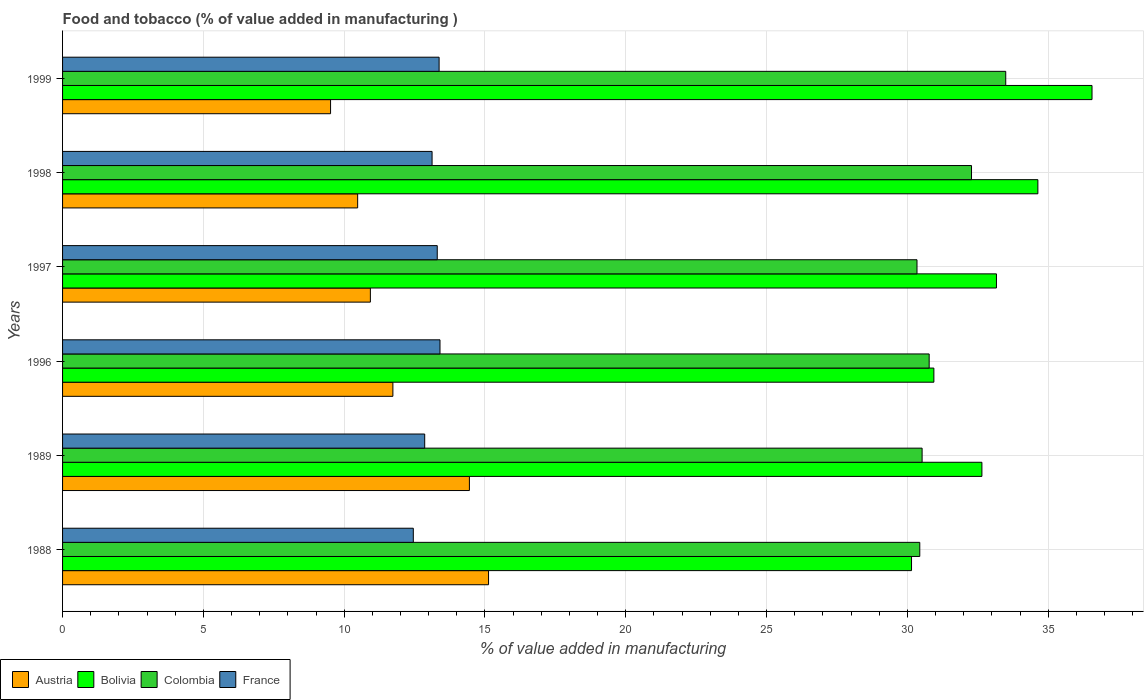How many bars are there on the 6th tick from the top?
Provide a succinct answer. 4. What is the label of the 1st group of bars from the top?
Ensure brevity in your answer.  1999. What is the value added in manufacturing food and tobacco in Bolivia in 1999?
Make the answer very short. 36.56. Across all years, what is the maximum value added in manufacturing food and tobacco in Colombia?
Offer a very short reply. 33.49. Across all years, what is the minimum value added in manufacturing food and tobacco in France?
Your response must be concise. 12.45. In which year was the value added in manufacturing food and tobacco in Austria maximum?
Make the answer very short. 1988. What is the total value added in manufacturing food and tobacco in Bolivia in the graph?
Your answer should be very brief. 198.08. What is the difference between the value added in manufacturing food and tobacco in Bolivia in 1996 and that in 1997?
Your answer should be compact. -2.22. What is the difference between the value added in manufacturing food and tobacco in France in 1998 and the value added in manufacturing food and tobacco in Austria in 1997?
Offer a very short reply. 2.19. What is the average value added in manufacturing food and tobacco in Colombia per year?
Give a very brief answer. 31.31. In the year 1997, what is the difference between the value added in manufacturing food and tobacco in France and value added in manufacturing food and tobacco in Austria?
Give a very brief answer. 2.37. What is the ratio of the value added in manufacturing food and tobacco in France in 1988 to that in 1997?
Give a very brief answer. 0.94. Is the value added in manufacturing food and tobacco in Austria in 1988 less than that in 1989?
Provide a succinct answer. No. What is the difference between the highest and the second highest value added in manufacturing food and tobacco in Colombia?
Give a very brief answer. 1.22. What is the difference between the highest and the lowest value added in manufacturing food and tobacco in Bolivia?
Provide a short and direct response. 6.41. In how many years, is the value added in manufacturing food and tobacco in France greater than the average value added in manufacturing food and tobacco in France taken over all years?
Provide a succinct answer. 4. Is the sum of the value added in manufacturing food and tobacco in Austria in 1989 and 1999 greater than the maximum value added in manufacturing food and tobacco in France across all years?
Offer a terse response. Yes. What does the 3rd bar from the bottom in 1996 represents?
Give a very brief answer. Colombia. Is it the case that in every year, the sum of the value added in manufacturing food and tobacco in Colombia and value added in manufacturing food and tobacco in Bolivia is greater than the value added in manufacturing food and tobacco in Austria?
Your answer should be compact. Yes. How many bars are there?
Keep it short and to the point. 24. Does the graph contain any zero values?
Your answer should be very brief. No. How are the legend labels stacked?
Your response must be concise. Horizontal. What is the title of the graph?
Offer a terse response. Food and tobacco (% of value added in manufacturing ). Does "Bosnia and Herzegovina" appear as one of the legend labels in the graph?
Ensure brevity in your answer.  No. What is the label or title of the X-axis?
Provide a succinct answer. % of value added in manufacturing. What is the label or title of the Y-axis?
Offer a very short reply. Years. What is the % of value added in manufacturing of Austria in 1988?
Provide a short and direct response. 15.13. What is the % of value added in manufacturing of Bolivia in 1988?
Offer a terse response. 30.15. What is the % of value added in manufacturing in Colombia in 1988?
Your response must be concise. 30.44. What is the % of value added in manufacturing in France in 1988?
Keep it short and to the point. 12.45. What is the % of value added in manufacturing of Austria in 1989?
Ensure brevity in your answer.  14.45. What is the % of value added in manufacturing in Bolivia in 1989?
Provide a short and direct response. 32.65. What is the % of value added in manufacturing of Colombia in 1989?
Your response must be concise. 30.52. What is the % of value added in manufacturing of France in 1989?
Ensure brevity in your answer.  12.86. What is the % of value added in manufacturing of Austria in 1996?
Offer a terse response. 11.73. What is the % of value added in manufacturing in Bolivia in 1996?
Offer a terse response. 30.94. What is the % of value added in manufacturing of Colombia in 1996?
Provide a succinct answer. 30.77. What is the % of value added in manufacturing in France in 1996?
Your response must be concise. 13.4. What is the % of value added in manufacturing of Austria in 1997?
Make the answer very short. 10.93. What is the % of value added in manufacturing of Bolivia in 1997?
Keep it short and to the point. 33.16. What is the % of value added in manufacturing of Colombia in 1997?
Keep it short and to the point. 30.34. What is the % of value added in manufacturing in France in 1997?
Your answer should be compact. 13.31. What is the % of value added in manufacturing in Austria in 1998?
Provide a short and direct response. 10.48. What is the % of value added in manufacturing of Bolivia in 1998?
Your answer should be compact. 34.63. What is the % of value added in manufacturing of Colombia in 1998?
Make the answer very short. 32.28. What is the % of value added in manufacturing of France in 1998?
Give a very brief answer. 13.12. What is the % of value added in manufacturing in Austria in 1999?
Offer a terse response. 9.52. What is the % of value added in manufacturing of Bolivia in 1999?
Offer a very short reply. 36.56. What is the % of value added in manufacturing in Colombia in 1999?
Offer a terse response. 33.49. What is the % of value added in manufacturing in France in 1999?
Offer a terse response. 13.37. Across all years, what is the maximum % of value added in manufacturing of Austria?
Offer a terse response. 15.13. Across all years, what is the maximum % of value added in manufacturing of Bolivia?
Make the answer very short. 36.56. Across all years, what is the maximum % of value added in manufacturing in Colombia?
Give a very brief answer. 33.49. Across all years, what is the maximum % of value added in manufacturing in France?
Offer a very short reply. 13.4. Across all years, what is the minimum % of value added in manufacturing in Austria?
Offer a very short reply. 9.52. Across all years, what is the minimum % of value added in manufacturing in Bolivia?
Provide a short and direct response. 30.15. Across all years, what is the minimum % of value added in manufacturing in Colombia?
Ensure brevity in your answer.  30.34. Across all years, what is the minimum % of value added in manufacturing in France?
Your answer should be very brief. 12.45. What is the total % of value added in manufacturing of Austria in the graph?
Offer a terse response. 72.23. What is the total % of value added in manufacturing in Bolivia in the graph?
Keep it short and to the point. 198.08. What is the total % of value added in manufacturing of Colombia in the graph?
Your answer should be very brief. 187.85. What is the total % of value added in manufacturing of France in the graph?
Ensure brevity in your answer.  78.51. What is the difference between the % of value added in manufacturing in Austria in 1988 and that in 1989?
Provide a short and direct response. 0.68. What is the difference between the % of value added in manufacturing in Bolivia in 1988 and that in 1989?
Keep it short and to the point. -2.5. What is the difference between the % of value added in manufacturing of Colombia in 1988 and that in 1989?
Your response must be concise. -0.08. What is the difference between the % of value added in manufacturing in France in 1988 and that in 1989?
Offer a very short reply. -0.4. What is the difference between the % of value added in manufacturing of Austria in 1988 and that in 1996?
Offer a very short reply. 3.4. What is the difference between the % of value added in manufacturing of Bolivia in 1988 and that in 1996?
Your answer should be very brief. -0.79. What is the difference between the % of value added in manufacturing of Colombia in 1988 and that in 1996?
Your answer should be very brief. -0.33. What is the difference between the % of value added in manufacturing of France in 1988 and that in 1996?
Ensure brevity in your answer.  -0.95. What is the difference between the % of value added in manufacturing of Austria in 1988 and that in 1997?
Your answer should be very brief. 4.2. What is the difference between the % of value added in manufacturing of Bolivia in 1988 and that in 1997?
Offer a terse response. -3.02. What is the difference between the % of value added in manufacturing in Colombia in 1988 and that in 1997?
Your answer should be compact. 0.1. What is the difference between the % of value added in manufacturing in France in 1988 and that in 1997?
Offer a very short reply. -0.85. What is the difference between the % of value added in manufacturing of Austria in 1988 and that in 1998?
Provide a short and direct response. 4.65. What is the difference between the % of value added in manufacturing of Bolivia in 1988 and that in 1998?
Keep it short and to the point. -4.49. What is the difference between the % of value added in manufacturing of Colombia in 1988 and that in 1998?
Give a very brief answer. -1.84. What is the difference between the % of value added in manufacturing of France in 1988 and that in 1998?
Your answer should be very brief. -0.67. What is the difference between the % of value added in manufacturing of Austria in 1988 and that in 1999?
Provide a succinct answer. 5.61. What is the difference between the % of value added in manufacturing in Bolivia in 1988 and that in 1999?
Your answer should be very brief. -6.41. What is the difference between the % of value added in manufacturing in Colombia in 1988 and that in 1999?
Your response must be concise. -3.05. What is the difference between the % of value added in manufacturing of France in 1988 and that in 1999?
Your answer should be compact. -0.92. What is the difference between the % of value added in manufacturing in Austria in 1989 and that in 1996?
Ensure brevity in your answer.  2.72. What is the difference between the % of value added in manufacturing of Bolivia in 1989 and that in 1996?
Give a very brief answer. 1.71. What is the difference between the % of value added in manufacturing of Colombia in 1989 and that in 1996?
Offer a very short reply. -0.25. What is the difference between the % of value added in manufacturing in France in 1989 and that in 1996?
Give a very brief answer. -0.54. What is the difference between the % of value added in manufacturing of Austria in 1989 and that in 1997?
Ensure brevity in your answer.  3.52. What is the difference between the % of value added in manufacturing in Bolivia in 1989 and that in 1997?
Ensure brevity in your answer.  -0.52. What is the difference between the % of value added in manufacturing in Colombia in 1989 and that in 1997?
Give a very brief answer. 0.18. What is the difference between the % of value added in manufacturing of France in 1989 and that in 1997?
Provide a short and direct response. -0.45. What is the difference between the % of value added in manufacturing of Austria in 1989 and that in 1998?
Ensure brevity in your answer.  3.97. What is the difference between the % of value added in manufacturing in Bolivia in 1989 and that in 1998?
Offer a very short reply. -1.99. What is the difference between the % of value added in manufacturing of Colombia in 1989 and that in 1998?
Ensure brevity in your answer.  -1.75. What is the difference between the % of value added in manufacturing in France in 1989 and that in 1998?
Your answer should be compact. -0.26. What is the difference between the % of value added in manufacturing of Austria in 1989 and that in 1999?
Provide a succinct answer. 4.93. What is the difference between the % of value added in manufacturing of Bolivia in 1989 and that in 1999?
Keep it short and to the point. -3.91. What is the difference between the % of value added in manufacturing of Colombia in 1989 and that in 1999?
Make the answer very short. -2.97. What is the difference between the % of value added in manufacturing of France in 1989 and that in 1999?
Ensure brevity in your answer.  -0.51. What is the difference between the % of value added in manufacturing of Austria in 1996 and that in 1997?
Make the answer very short. 0.8. What is the difference between the % of value added in manufacturing in Bolivia in 1996 and that in 1997?
Your answer should be very brief. -2.22. What is the difference between the % of value added in manufacturing in Colombia in 1996 and that in 1997?
Your response must be concise. 0.43. What is the difference between the % of value added in manufacturing of France in 1996 and that in 1997?
Provide a short and direct response. 0.1. What is the difference between the % of value added in manufacturing of Austria in 1996 and that in 1998?
Your answer should be very brief. 1.25. What is the difference between the % of value added in manufacturing in Bolivia in 1996 and that in 1998?
Make the answer very short. -3.69. What is the difference between the % of value added in manufacturing of Colombia in 1996 and that in 1998?
Provide a succinct answer. -1.5. What is the difference between the % of value added in manufacturing of France in 1996 and that in 1998?
Provide a short and direct response. 0.28. What is the difference between the % of value added in manufacturing of Austria in 1996 and that in 1999?
Ensure brevity in your answer.  2.21. What is the difference between the % of value added in manufacturing in Bolivia in 1996 and that in 1999?
Your response must be concise. -5.62. What is the difference between the % of value added in manufacturing in Colombia in 1996 and that in 1999?
Offer a terse response. -2.72. What is the difference between the % of value added in manufacturing of France in 1996 and that in 1999?
Ensure brevity in your answer.  0.03. What is the difference between the % of value added in manufacturing in Austria in 1997 and that in 1998?
Your response must be concise. 0.45. What is the difference between the % of value added in manufacturing of Bolivia in 1997 and that in 1998?
Keep it short and to the point. -1.47. What is the difference between the % of value added in manufacturing of Colombia in 1997 and that in 1998?
Provide a succinct answer. -1.94. What is the difference between the % of value added in manufacturing of France in 1997 and that in 1998?
Keep it short and to the point. 0.18. What is the difference between the % of value added in manufacturing of Austria in 1997 and that in 1999?
Provide a succinct answer. 1.41. What is the difference between the % of value added in manufacturing of Bolivia in 1997 and that in 1999?
Your answer should be compact. -3.39. What is the difference between the % of value added in manufacturing in Colombia in 1997 and that in 1999?
Offer a terse response. -3.15. What is the difference between the % of value added in manufacturing of France in 1997 and that in 1999?
Your response must be concise. -0.07. What is the difference between the % of value added in manufacturing of Austria in 1998 and that in 1999?
Offer a very short reply. 0.96. What is the difference between the % of value added in manufacturing in Bolivia in 1998 and that in 1999?
Give a very brief answer. -1.92. What is the difference between the % of value added in manufacturing in Colombia in 1998 and that in 1999?
Your answer should be compact. -1.22. What is the difference between the % of value added in manufacturing in France in 1998 and that in 1999?
Ensure brevity in your answer.  -0.25. What is the difference between the % of value added in manufacturing in Austria in 1988 and the % of value added in manufacturing in Bolivia in 1989?
Offer a terse response. -17.52. What is the difference between the % of value added in manufacturing of Austria in 1988 and the % of value added in manufacturing of Colombia in 1989?
Provide a short and direct response. -15.4. What is the difference between the % of value added in manufacturing in Austria in 1988 and the % of value added in manufacturing in France in 1989?
Offer a terse response. 2.27. What is the difference between the % of value added in manufacturing of Bolivia in 1988 and the % of value added in manufacturing of Colombia in 1989?
Keep it short and to the point. -0.38. What is the difference between the % of value added in manufacturing of Bolivia in 1988 and the % of value added in manufacturing of France in 1989?
Give a very brief answer. 17.29. What is the difference between the % of value added in manufacturing in Colombia in 1988 and the % of value added in manufacturing in France in 1989?
Give a very brief answer. 17.58. What is the difference between the % of value added in manufacturing of Austria in 1988 and the % of value added in manufacturing of Bolivia in 1996?
Your answer should be very brief. -15.81. What is the difference between the % of value added in manufacturing of Austria in 1988 and the % of value added in manufacturing of Colombia in 1996?
Provide a short and direct response. -15.65. What is the difference between the % of value added in manufacturing in Austria in 1988 and the % of value added in manufacturing in France in 1996?
Ensure brevity in your answer.  1.72. What is the difference between the % of value added in manufacturing of Bolivia in 1988 and the % of value added in manufacturing of Colombia in 1996?
Your answer should be compact. -0.63. What is the difference between the % of value added in manufacturing in Bolivia in 1988 and the % of value added in manufacturing in France in 1996?
Keep it short and to the point. 16.74. What is the difference between the % of value added in manufacturing in Colombia in 1988 and the % of value added in manufacturing in France in 1996?
Ensure brevity in your answer.  17.04. What is the difference between the % of value added in manufacturing in Austria in 1988 and the % of value added in manufacturing in Bolivia in 1997?
Provide a short and direct response. -18.04. What is the difference between the % of value added in manufacturing of Austria in 1988 and the % of value added in manufacturing of Colombia in 1997?
Offer a very short reply. -15.21. What is the difference between the % of value added in manufacturing of Austria in 1988 and the % of value added in manufacturing of France in 1997?
Ensure brevity in your answer.  1.82. What is the difference between the % of value added in manufacturing of Bolivia in 1988 and the % of value added in manufacturing of Colombia in 1997?
Offer a terse response. -0.19. What is the difference between the % of value added in manufacturing of Bolivia in 1988 and the % of value added in manufacturing of France in 1997?
Offer a very short reply. 16.84. What is the difference between the % of value added in manufacturing of Colombia in 1988 and the % of value added in manufacturing of France in 1997?
Offer a very short reply. 17.13. What is the difference between the % of value added in manufacturing of Austria in 1988 and the % of value added in manufacturing of Bolivia in 1998?
Your answer should be very brief. -19.51. What is the difference between the % of value added in manufacturing in Austria in 1988 and the % of value added in manufacturing in Colombia in 1998?
Provide a short and direct response. -17.15. What is the difference between the % of value added in manufacturing in Austria in 1988 and the % of value added in manufacturing in France in 1998?
Provide a short and direct response. 2.01. What is the difference between the % of value added in manufacturing in Bolivia in 1988 and the % of value added in manufacturing in Colombia in 1998?
Make the answer very short. -2.13. What is the difference between the % of value added in manufacturing of Bolivia in 1988 and the % of value added in manufacturing of France in 1998?
Make the answer very short. 17.03. What is the difference between the % of value added in manufacturing of Colombia in 1988 and the % of value added in manufacturing of France in 1998?
Offer a terse response. 17.32. What is the difference between the % of value added in manufacturing in Austria in 1988 and the % of value added in manufacturing in Bolivia in 1999?
Make the answer very short. -21.43. What is the difference between the % of value added in manufacturing of Austria in 1988 and the % of value added in manufacturing of Colombia in 1999?
Offer a very short reply. -18.37. What is the difference between the % of value added in manufacturing in Austria in 1988 and the % of value added in manufacturing in France in 1999?
Provide a succinct answer. 1.76. What is the difference between the % of value added in manufacturing of Bolivia in 1988 and the % of value added in manufacturing of Colombia in 1999?
Your answer should be very brief. -3.35. What is the difference between the % of value added in manufacturing in Bolivia in 1988 and the % of value added in manufacturing in France in 1999?
Your answer should be compact. 16.78. What is the difference between the % of value added in manufacturing of Colombia in 1988 and the % of value added in manufacturing of France in 1999?
Your answer should be compact. 17.07. What is the difference between the % of value added in manufacturing of Austria in 1989 and the % of value added in manufacturing of Bolivia in 1996?
Offer a terse response. -16.49. What is the difference between the % of value added in manufacturing of Austria in 1989 and the % of value added in manufacturing of Colombia in 1996?
Your response must be concise. -16.33. What is the difference between the % of value added in manufacturing of Austria in 1989 and the % of value added in manufacturing of France in 1996?
Give a very brief answer. 1.04. What is the difference between the % of value added in manufacturing of Bolivia in 1989 and the % of value added in manufacturing of Colombia in 1996?
Offer a terse response. 1.87. What is the difference between the % of value added in manufacturing in Bolivia in 1989 and the % of value added in manufacturing in France in 1996?
Provide a succinct answer. 19.24. What is the difference between the % of value added in manufacturing of Colombia in 1989 and the % of value added in manufacturing of France in 1996?
Your response must be concise. 17.12. What is the difference between the % of value added in manufacturing of Austria in 1989 and the % of value added in manufacturing of Bolivia in 1997?
Keep it short and to the point. -18.71. What is the difference between the % of value added in manufacturing in Austria in 1989 and the % of value added in manufacturing in Colombia in 1997?
Your answer should be compact. -15.89. What is the difference between the % of value added in manufacturing of Austria in 1989 and the % of value added in manufacturing of France in 1997?
Offer a terse response. 1.14. What is the difference between the % of value added in manufacturing in Bolivia in 1989 and the % of value added in manufacturing in Colombia in 1997?
Offer a terse response. 2.3. What is the difference between the % of value added in manufacturing of Bolivia in 1989 and the % of value added in manufacturing of France in 1997?
Your answer should be compact. 19.34. What is the difference between the % of value added in manufacturing of Colombia in 1989 and the % of value added in manufacturing of France in 1997?
Offer a terse response. 17.22. What is the difference between the % of value added in manufacturing of Austria in 1989 and the % of value added in manufacturing of Bolivia in 1998?
Your answer should be very brief. -20.19. What is the difference between the % of value added in manufacturing in Austria in 1989 and the % of value added in manufacturing in Colombia in 1998?
Give a very brief answer. -17.83. What is the difference between the % of value added in manufacturing of Austria in 1989 and the % of value added in manufacturing of France in 1998?
Provide a short and direct response. 1.33. What is the difference between the % of value added in manufacturing of Bolivia in 1989 and the % of value added in manufacturing of Colombia in 1998?
Offer a very short reply. 0.37. What is the difference between the % of value added in manufacturing in Bolivia in 1989 and the % of value added in manufacturing in France in 1998?
Make the answer very short. 19.52. What is the difference between the % of value added in manufacturing in Colombia in 1989 and the % of value added in manufacturing in France in 1998?
Your response must be concise. 17.4. What is the difference between the % of value added in manufacturing of Austria in 1989 and the % of value added in manufacturing of Bolivia in 1999?
Make the answer very short. -22.11. What is the difference between the % of value added in manufacturing of Austria in 1989 and the % of value added in manufacturing of Colombia in 1999?
Offer a very short reply. -19.04. What is the difference between the % of value added in manufacturing in Austria in 1989 and the % of value added in manufacturing in France in 1999?
Give a very brief answer. 1.08. What is the difference between the % of value added in manufacturing in Bolivia in 1989 and the % of value added in manufacturing in Colombia in 1999?
Offer a very short reply. -0.85. What is the difference between the % of value added in manufacturing in Bolivia in 1989 and the % of value added in manufacturing in France in 1999?
Offer a very short reply. 19.27. What is the difference between the % of value added in manufacturing of Colombia in 1989 and the % of value added in manufacturing of France in 1999?
Your answer should be very brief. 17.15. What is the difference between the % of value added in manufacturing of Austria in 1996 and the % of value added in manufacturing of Bolivia in 1997?
Your answer should be compact. -21.43. What is the difference between the % of value added in manufacturing of Austria in 1996 and the % of value added in manufacturing of Colombia in 1997?
Provide a short and direct response. -18.61. What is the difference between the % of value added in manufacturing in Austria in 1996 and the % of value added in manufacturing in France in 1997?
Make the answer very short. -1.58. What is the difference between the % of value added in manufacturing in Bolivia in 1996 and the % of value added in manufacturing in Colombia in 1997?
Your response must be concise. 0.6. What is the difference between the % of value added in manufacturing of Bolivia in 1996 and the % of value added in manufacturing of France in 1997?
Your answer should be compact. 17.64. What is the difference between the % of value added in manufacturing in Colombia in 1996 and the % of value added in manufacturing in France in 1997?
Give a very brief answer. 17.47. What is the difference between the % of value added in manufacturing of Austria in 1996 and the % of value added in manufacturing of Bolivia in 1998?
Keep it short and to the point. -22.9. What is the difference between the % of value added in manufacturing of Austria in 1996 and the % of value added in manufacturing of Colombia in 1998?
Provide a short and direct response. -20.55. What is the difference between the % of value added in manufacturing of Austria in 1996 and the % of value added in manufacturing of France in 1998?
Give a very brief answer. -1.39. What is the difference between the % of value added in manufacturing of Bolivia in 1996 and the % of value added in manufacturing of Colombia in 1998?
Provide a short and direct response. -1.34. What is the difference between the % of value added in manufacturing in Bolivia in 1996 and the % of value added in manufacturing in France in 1998?
Provide a short and direct response. 17.82. What is the difference between the % of value added in manufacturing of Colombia in 1996 and the % of value added in manufacturing of France in 1998?
Offer a terse response. 17.65. What is the difference between the % of value added in manufacturing in Austria in 1996 and the % of value added in manufacturing in Bolivia in 1999?
Ensure brevity in your answer.  -24.83. What is the difference between the % of value added in manufacturing in Austria in 1996 and the % of value added in manufacturing in Colombia in 1999?
Your answer should be very brief. -21.76. What is the difference between the % of value added in manufacturing in Austria in 1996 and the % of value added in manufacturing in France in 1999?
Your answer should be very brief. -1.64. What is the difference between the % of value added in manufacturing of Bolivia in 1996 and the % of value added in manufacturing of Colombia in 1999?
Your answer should be very brief. -2.55. What is the difference between the % of value added in manufacturing of Bolivia in 1996 and the % of value added in manufacturing of France in 1999?
Keep it short and to the point. 17.57. What is the difference between the % of value added in manufacturing of Colombia in 1996 and the % of value added in manufacturing of France in 1999?
Give a very brief answer. 17.4. What is the difference between the % of value added in manufacturing of Austria in 1997 and the % of value added in manufacturing of Bolivia in 1998?
Ensure brevity in your answer.  -23.7. What is the difference between the % of value added in manufacturing in Austria in 1997 and the % of value added in manufacturing in Colombia in 1998?
Your answer should be very brief. -21.35. What is the difference between the % of value added in manufacturing of Austria in 1997 and the % of value added in manufacturing of France in 1998?
Give a very brief answer. -2.19. What is the difference between the % of value added in manufacturing in Bolivia in 1997 and the % of value added in manufacturing in Colombia in 1998?
Provide a short and direct response. 0.89. What is the difference between the % of value added in manufacturing in Bolivia in 1997 and the % of value added in manufacturing in France in 1998?
Your response must be concise. 20.04. What is the difference between the % of value added in manufacturing in Colombia in 1997 and the % of value added in manufacturing in France in 1998?
Ensure brevity in your answer.  17.22. What is the difference between the % of value added in manufacturing of Austria in 1997 and the % of value added in manufacturing of Bolivia in 1999?
Ensure brevity in your answer.  -25.63. What is the difference between the % of value added in manufacturing in Austria in 1997 and the % of value added in manufacturing in Colombia in 1999?
Provide a succinct answer. -22.56. What is the difference between the % of value added in manufacturing of Austria in 1997 and the % of value added in manufacturing of France in 1999?
Give a very brief answer. -2.44. What is the difference between the % of value added in manufacturing in Bolivia in 1997 and the % of value added in manufacturing in Colombia in 1999?
Your response must be concise. -0.33. What is the difference between the % of value added in manufacturing of Bolivia in 1997 and the % of value added in manufacturing of France in 1999?
Ensure brevity in your answer.  19.79. What is the difference between the % of value added in manufacturing in Colombia in 1997 and the % of value added in manufacturing in France in 1999?
Your answer should be compact. 16.97. What is the difference between the % of value added in manufacturing in Austria in 1998 and the % of value added in manufacturing in Bolivia in 1999?
Offer a very short reply. -26.08. What is the difference between the % of value added in manufacturing in Austria in 1998 and the % of value added in manufacturing in Colombia in 1999?
Provide a succinct answer. -23.01. What is the difference between the % of value added in manufacturing of Austria in 1998 and the % of value added in manufacturing of France in 1999?
Your answer should be compact. -2.89. What is the difference between the % of value added in manufacturing of Bolivia in 1998 and the % of value added in manufacturing of Colombia in 1999?
Make the answer very short. 1.14. What is the difference between the % of value added in manufacturing in Bolivia in 1998 and the % of value added in manufacturing in France in 1999?
Offer a very short reply. 21.26. What is the difference between the % of value added in manufacturing of Colombia in 1998 and the % of value added in manufacturing of France in 1999?
Ensure brevity in your answer.  18.91. What is the average % of value added in manufacturing in Austria per year?
Keep it short and to the point. 12.04. What is the average % of value added in manufacturing in Bolivia per year?
Make the answer very short. 33.01. What is the average % of value added in manufacturing of Colombia per year?
Provide a succinct answer. 31.31. What is the average % of value added in manufacturing of France per year?
Your answer should be compact. 13.09. In the year 1988, what is the difference between the % of value added in manufacturing of Austria and % of value added in manufacturing of Bolivia?
Make the answer very short. -15.02. In the year 1988, what is the difference between the % of value added in manufacturing of Austria and % of value added in manufacturing of Colombia?
Provide a succinct answer. -15.31. In the year 1988, what is the difference between the % of value added in manufacturing in Austria and % of value added in manufacturing in France?
Ensure brevity in your answer.  2.67. In the year 1988, what is the difference between the % of value added in manufacturing in Bolivia and % of value added in manufacturing in Colombia?
Keep it short and to the point. -0.29. In the year 1988, what is the difference between the % of value added in manufacturing in Bolivia and % of value added in manufacturing in France?
Offer a terse response. 17.69. In the year 1988, what is the difference between the % of value added in manufacturing in Colombia and % of value added in manufacturing in France?
Offer a terse response. 17.99. In the year 1989, what is the difference between the % of value added in manufacturing of Austria and % of value added in manufacturing of Bolivia?
Give a very brief answer. -18.2. In the year 1989, what is the difference between the % of value added in manufacturing of Austria and % of value added in manufacturing of Colombia?
Provide a succinct answer. -16.08. In the year 1989, what is the difference between the % of value added in manufacturing in Austria and % of value added in manufacturing in France?
Provide a short and direct response. 1.59. In the year 1989, what is the difference between the % of value added in manufacturing of Bolivia and % of value added in manufacturing of Colombia?
Give a very brief answer. 2.12. In the year 1989, what is the difference between the % of value added in manufacturing of Bolivia and % of value added in manufacturing of France?
Make the answer very short. 19.79. In the year 1989, what is the difference between the % of value added in manufacturing in Colombia and % of value added in manufacturing in France?
Your answer should be compact. 17.66. In the year 1996, what is the difference between the % of value added in manufacturing of Austria and % of value added in manufacturing of Bolivia?
Make the answer very short. -19.21. In the year 1996, what is the difference between the % of value added in manufacturing in Austria and % of value added in manufacturing in Colombia?
Provide a succinct answer. -19.04. In the year 1996, what is the difference between the % of value added in manufacturing of Austria and % of value added in manufacturing of France?
Provide a short and direct response. -1.67. In the year 1996, what is the difference between the % of value added in manufacturing in Bolivia and % of value added in manufacturing in Colombia?
Offer a terse response. 0.17. In the year 1996, what is the difference between the % of value added in manufacturing in Bolivia and % of value added in manufacturing in France?
Keep it short and to the point. 17.54. In the year 1996, what is the difference between the % of value added in manufacturing of Colombia and % of value added in manufacturing of France?
Provide a succinct answer. 17.37. In the year 1997, what is the difference between the % of value added in manufacturing in Austria and % of value added in manufacturing in Bolivia?
Give a very brief answer. -22.23. In the year 1997, what is the difference between the % of value added in manufacturing in Austria and % of value added in manufacturing in Colombia?
Keep it short and to the point. -19.41. In the year 1997, what is the difference between the % of value added in manufacturing in Austria and % of value added in manufacturing in France?
Give a very brief answer. -2.37. In the year 1997, what is the difference between the % of value added in manufacturing of Bolivia and % of value added in manufacturing of Colombia?
Keep it short and to the point. 2.82. In the year 1997, what is the difference between the % of value added in manufacturing of Bolivia and % of value added in manufacturing of France?
Ensure brevity in your answer.  19.86. In the year 1997, what is the difference between the % of value added in manufacturing in Colombia and % of value added in manufacturing in France?
Your answer should be compact. 17.04. In the year 1998, what is the difference between the % of value added in manufacturing of Austria and % of value added in manufacturing of Bolivia?
Make the answer very short. -24.15. In the year 1998, what is the difference between the % of value added in manufacturing of Austria and % of value added in manufacturing of Colombia?
Keep it short and to the point. -21.8. In the year 1998, what is the difference between the % of value added in manufacturing in Austria and % of value added in manufacturing in France?
Your answer should be compact. -2.64. In the year 1998, what is the difference between the % of value added in manufacturing in Bolivia and % of value added in manufacturing in Colombia?
Keep it short and to the point. 2.36. In the year 1998, what is the difference between the % of value added in manufacturing in Bolivia and % of value added in manufacturing in France?
Keep it short and to the point. 21.51. In the year 1998, what is the difference between the % of value added in manufacturing of Colombia and % of value added in manufacturing of France?
Keep it short and to the point. 19.16. In the year 1999, what is the difference between the % of value added in manufacturing in Austria and % of value added in manufacturing in Bolivia?
Your answer should be very brief. -27.04. In the year 1999, what is the difference between the % of value added in manufacturing of Austria and % of value added in manufacturing of Colombia?
Keep it short and to the point. -23.98. In the year 1999, what is the difference between the % of value added in manufacturing of Austria and % of value added in manufacturing of France?
Your response must be concise. -3.85. In the year 1999, what is the difference between the % of value added in manufacturing in Bolivia and % of value added in manufacturing in Colombia?
Offer a terse response. 3.06. In the year 1999, what is the difference between the % of value added in manufacturing in Bolivia and % of value added in manufacturing in France?
Give a very brief answer. 23.18. In the year 1999, what is the difference between the % of value added in manufacturing in Colombia and % of value added in manufacturing in France?
Your answer should be very brief. 20.12. What is the ratio of the % of value added in manufacturing in Austria in 1988 to that in 1989?
Provide a short and direct response. 1.05. What is the ratio of the % of value added in manufacturing of Bolivia in 1988 to that in 1989?
Keep it short and to the point. 0.92. What is the ratio of the % of value added in manufacturing in France in 1988 to that in 1989?
Provide a succinct answer. 0.97. What is the ratio of the % of value added in manufacturing of Austria in 1988 to that in 1996?
Your answer should be compact. 1.29. What is the ratio of the % of value added in manufacturing of Bolivia in 1988 to that in 1996?
Your answer should be compact. 0.97. What is the ratio of the % of value added in manufacturing in Colombia in 1988 to that in 1996?
Offer a very short reply. 0.99. What is the ratio of the % of value added in manufacturing of France in 1988 to that in 1996?
Offer a very short reply. 0.93. What is the ratio of the % of value added in manufacturing of Austria in 1988 to that in 1997?
Your response must be concise. 1.38. What is the ratio of the % of value added in manufacturing in Bolivia in 1988 to that in 1997?
Offer a terse response. 0.91. What is the ratio of the % of value added in manufacturing of Colombia in 1988 to that in 1997?
Provide a short and direct response. 1. What is the ratio of the % of value added in manufacturing of France in 1988 to that in 1997?
Ensure brevity in your answer.  0.94. What is the ratio of the % of value added in manufacturing in Austria in 1988 to that in 1998?
Offer a very short reply. 1.44. What is the ratio of the % of value added in manufacturing in Bolivia in 1988 to that in 1998?
Your response must be concise. 0.87. What is the ratio of the % of value added in manufacturing in Colombia in 1988 to that in 1998?
Make the answer very short. 0.94. What is the ratio of the % of value added in manufacturing in France in 1988 to that in 1998?
Offer a very short reply. 0.95. What is the ratio of the % of value added in manufacturing in Austria in 1988 to that in 1999?
Give a very brief answer. 1.59. What is the ratio of the % of value added in manufacturing of Bolivia in 1988 to that in 1999?
Provide a short and direct response. 0.82. What is the ratio of the % of value added in manufacturing in Colombia in 1988 to that in 1999?
Give a very brief answer. 0.91. What is the ratio of the % of value added in manufacturing of France in 1988 to that in 1999?
Make the answer very short. 0.93. What is the ratio of the % of value added in manufacturing in Austria in 1989 to that in 1996?
Your answer should be compact. 1.23. What is the ratio of the % of value added in manufacturing of Bolivia in 1989 to that in 1996?
Your response must be concise. 1.06. What is the ratio of the % of value added in manufacturing in Colombia in 1989 to that in 1996?
Ensure brevity in your answer.  0.99. What is the ratio of the % of value added in manufacturing in France in 1989 to that in 1996?
Offer a very short reply. 0.96. What is the ratio of the % of value added in manufacturing of Austria in 1989 to that in 1997?
Offer a very short reply. 1.32. What is the ratio of the % of value added in manufacturing in Bolivia in 1989 to that in 1997?
Offer a very short reply. 0.98. What is the ratio of the % of value added in manufacturing in France in 1989 to that in 1997?
Provide a succinct answer. 0.97. What is the ratio of the % of value added in manufacturing of Austria in 1989 to that in 1998?
Your answer should be compact. 1.38. What is the ratio of the % of value added in manufacturing in Bolivia in 1989 to that in 1998?
Offer a terse response. 0.94. What is the ratio of the % of value added in manufacturing in Colombia in 1989 to that in 1998?
Offer a terse response. 0.95. What is the ratio of the % of value added in manufacturing of France in 1989 to that in 1998?
Give a very brief answer. 0.98. What is the ratio of the % of value added in manufacturing of Austria in 1989 to that in 1999?
Ensure brevity in your answer.  1.52. What is the ratio of the % of value added in manufacturing in Bolivia in 1989 to that in 1999?
Provide a succinct answer. 0.89. What is the ratio of the % of value added in manufacturing of Colombia in 1989 to that in 1999?
Provide a short and direct response. 0.91. What is the ratio of the % of value added in manufacturing of France in 1989 to that in 1999?
Ensure brevity in your answer.  0.96. What is the ratio of the % of value added in manufacturing of Austria in 1996 to that in 1997?
Your answer should be very brief. 1.07. What is the ratio of the % of value added in manufacturing of Bolivia in 1996 to that in 1997?
Make the answer very short. 0.93. What is the ratio of the % of value added in manufacturing of Colombia in 1996 to that in 1997?
Your response must be concise. 1.01. What is the ratio of the % of value added in manufacturing of France in 1996 to that in 1997?
Ensure brevity in your answer.  1.01. What is the ratio of the % of value added in manufacturing of Austria in 1996 to that in 1998?
Give a very brief answer. 1.12. What is the ratio of the % of value added in manufacturing in Bolivia in 1996 to that in 1998?
Keep it short and to the point. 0.89. What is the ratio of the % of value added in manufacturing in Colombia in 1996 to that in 1998?
Provide a succinct answer. 0.95. What is the ratio of the % of value added in manufacturing in France in 1996 to that in 1998?
Ensure brevity in your answer.  1.02. What is the ratio of the % of value added in manufacturing in Austria in 1996 to that in 1999?
Give a very brief answer. 1.23. What is the ratio of the % of value added in manufacturing in Bolivia in 1996 to that in 1999?
Provide a short and direct response. 0.85. What is the ratio of the % of value added in manufacturing in Colombia in 1996 to that in 1999?
Offer a terse response. 0.92. What is the ratio of the % of value added in manufacturing of Austria in 1997 to that in 1998?
Ensure brevity in your answer.  1.04. What is the ratio of the % of value added in manufacturing of Bolivia in 1997 to that in 1998?
Make the answer very short. 0.96. What is the ratio of the % of value added in manufacturing in Colombia in 1997 to that in 1998?
Ensure brevity in your answer.  0.94. What is the ratio of the % of value added in manufacturing in Austria in 1997 to that in 1999?
Your answer should be very brief. 1.15. What is the ratio of the % of value added in manufacturing in Bolivia in 1997 to that in 1999?
Provide a succinct answer. 0.91. What is the ratio of the % of value added in manufacturing in Colombia in 1997 to that in 1999?
Offer a very short reply. 0.91. What is the ratio of the % of value added in manufacturing of France in 1997 to that in 1999?
Your answer should be very brief. 1. What is the ratio of the % of value added in manufacturing in Austria in 1998 to that in 1999?
Provide a short and direct response. 1.1. What is the ratio of the % of value added in manufacturing of Colombia in 1998 to that in 1999?
Provide a succinct answer. 0.96. What is the ratio of the % of value added in manufacturing in France in 1998 to that in 1999?
Your response must be concise. 0.98. What is the difference between the highest and the second highest % of value added in manufacturing in Austria?
Make the answer very short. 0.68. What is the difference between the highest and the second highest % of value added in manufacturing of Bolivia?
Keep it short and to the point. 1.92. What is the difference between the highest and the second highest % of value added in manufacturing in Colombia?
Offer a terse response. 1.22. What is the difference between the highest and the second highest % of value added in manufacturing of France?
Ensure brevity in your answer.  0.03. What is the difference between the highest and the lowest % of value added in manufacturing of Austria?
Ensure brevity in your answer.  5.61. What is the difference between the highest and the lowest % of value added in manufacturing in Bolivia?
Your response must be concise. 6.41. What is the difference between the highest and the lowest % of value added in manufacturing in Colombia?
Give a very brief answer. 3.15. What is the difference between the highest and the lowest % of value added in manufacturing of France?
Ensure brevity in your answer.  0.95. 